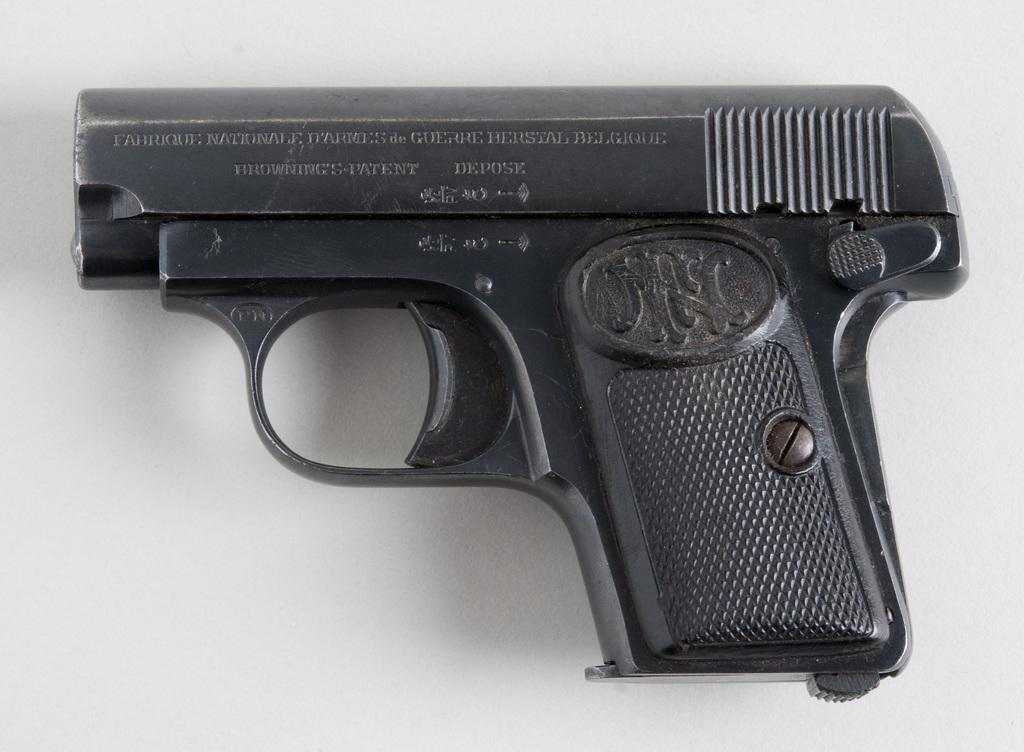What object is present on the table in the image? There is a gun on the table in the image. What type of turkey is being prepared on the table in the image? There is no turkey present in the image; it only features a gun on a table. What type of wire is connected to the gun in the image? There is no wire connected to the gun in the image; it is simply placed on the table. 